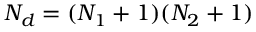<formula> <loc_0><loc_0><loc_500><loc_500>N _ { d } = ( N _ { 1 } + 1 ) ( N _ { 2 } + 1 )</formula> 